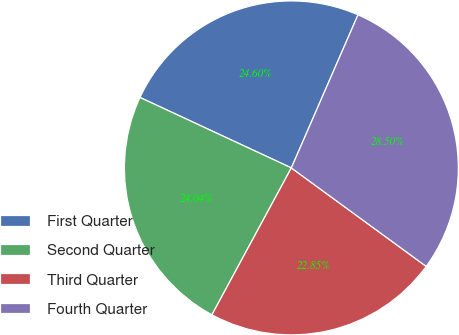Convert chart. <chart><loc_0><loc_0><loc_500><loc_500><pie_chart><fcel>First Quarter<fcel>Second Quarter<fcel>Third Quarter<fcel>Fourth Quarter<nl><fcel>24.6%<fcel>24.04%<fcel>22.85%<fcel>28.5%<nl></chart> 